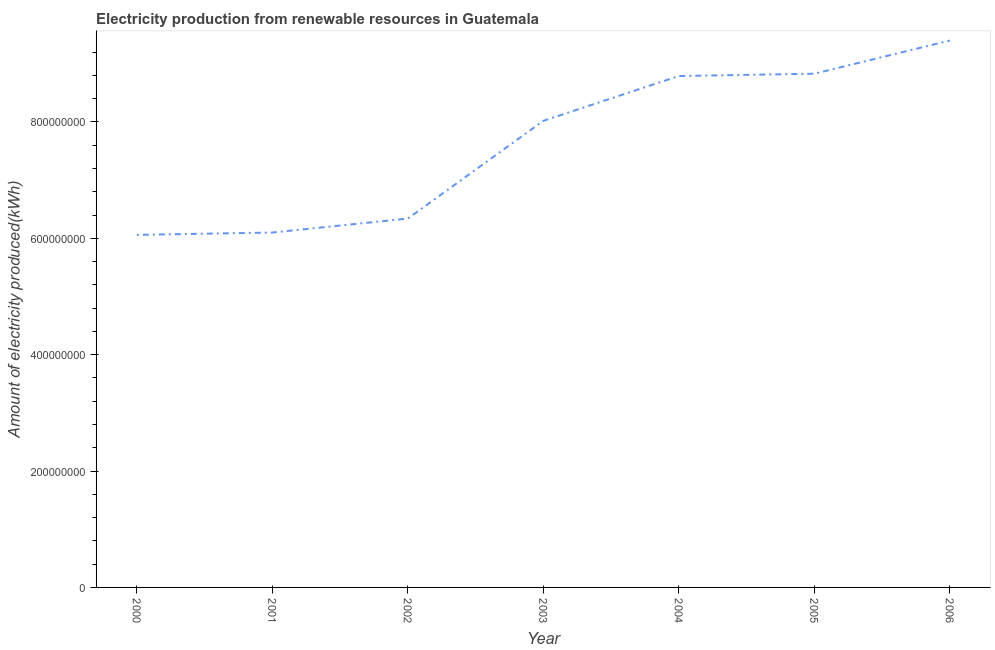What is the amount of electricity produced in 2001?
Your answer should be compact. 6.10e+08. Across all years, what is the maximum amount of electricity produced?
Make the answer very short. 9.40e+08. Across all years, what is the minimum amount of electricity produced?
Your answer should be very brief. 6.06e+08. In which year was the amount of electricity produced maximum?
Keep it short and to the point. 2006. In which year was the amount of electricity produced minimum?
Offer a very short reply. 2000. What is the sum of the amount of electricity produced?
Make the answer very short. 5.35e+09. What is the difference between the amount of electricity produced in 2001 and 2002?
Make the answer very short. -2.40e+07. What is the average amount of electricity produced per year?
Ensure brevity in your answer.  7.65e+08. What is the median amount of electricity produced?
Your answer should be compact. 8.02e+08. What is the ratio of the amount of electricity produced in 2001 to that in 2004?
Make the answer very short. 0.69. Is the amount of electricity produced in 2001 less than that in 2005?
Keep it short and to the point. Yes. What is the difference between the highest and the second highest amount of electricity produced?
Keep it short and to the point. 5.70e+07. Is the sum of the amount of electricity produced in 2001 and 2003 greater than the maximum amount of electricity produced across all years?
Provide a short and direct response. Yes. What is the difference between the highest and the lowest amount of electricity produced?
Ensure brevity in your answer.  3.34e+08. In how many years, is the amount of electricity produced greater than the average amount of electricity produced taken over all years?
Provide a short and direct response. 4. What is the difference between two consecutive major ticks on the Y-axis?
Keep it short and to the point. 2.00e+08. Does the graph contain any zero values?
Your answer should be compact. No. What is the title of the graph?
Your answer should be very brief. Electricity production from renewable resources in Guatemala. What is the label or title of the Y-axis?
Ensure brevity in your answer.  Amount of electricity produced(kWh). What is the Amount of electricity produced(kWh) in 2000?
Make the answer very short. 6.06e+08. What is the Amount of electricity produced(kWh) of 2001?
Your answer should be very brief. 6.10e+08. What is the Amount of electricity produced(kWh) in 2002?
Keep it short and to the point. 6.34e+08. What is the Amount of electricity produced(kWh) in 2003?
Keep it short and to the point. 8.02e+08. What is the Amount of electricity produced(kWh) of 2004?
Your response must be concise. 8.79e+08. What is the Amount of electricity produced(kWh) of 2005?
Offer a very short reply. 8.83e+08. What is the Amount of electricity produced(kWh) in 2006?
Your answer should be very brief. 9.40e+08. What is the difference between the Amount of electricity produced(kWh) in 2000 and 2001?
Ensure brevity in your answer.  -4.00e+06. What is the difference between the Amount of electricity produced(kWh) in 2000 and 2002?
Keep it short and to the point. -2.80e+07. What is the difference between the Amount of electricity produced(kWh) in 2000 and 2003?
Your answer should be compact. -1.96e+08. What is the difference between the Amount of electricity produced(kWh) in 2000 and 2004?
Keep it short and to the point. -2.73e+08. What is the difference between the Amount of electricity produced(kWh) in 2000 and 2005?
Make the answer very short. -2.77e+08. What is the difference between the Amount of electricity produced(kWh) in 2000 and 2006?
Your answer should be compact. -3.34e+08. What is the difference between the Amount of electricity produced(kWh) in 2001 and 2002?
Ensure brevity in your answer.  -2.40e+07. What is the difference between the Amount of electricity produced(kWh) in 2001 and 2003?
Your response must be concise. -1.92e+08. What is the difference between the Amount of electricity produced(kWh) in 2001 and 2004?
Ensure brevity in your answer.  -2.69e+08. What is the difference between the Amount of electricity produced(kWh) in 2001 and 2005?
Offer a very short reply. -2.73e+08. What is the difference between the Amount of electricity produced(kWh) in 2001 and 2006?
Offer a terse response. -3.30e+08. What is the difference between the Amount of electricity produced(kWh) in 2002 and 2003?
Your answer should be compact. -1.68e+08. What is the difference between the Amount of electricity produced(kWh) in 2002 and 2004?
Make the answer very short. -2.45e+08. What is the difference between the Amount of electricity produced(kWh) in 2002 and 2005?
Offer a very short reply. -2.49e+08. What is the difference between the Amount of electricity produced(kWh) in 2002 and 2006?
Your answer should be very brief. -3.06e+08. What is the difference between the Amount of electricity produced(kWh) in 2003 and 2004?
Your response must be concise. -7.70e+07. What is the difference between the Amount of electricity produced(kWh) in 2003 and 2005?
Ensure brevity in your answer.  -8.10e+07. What is the difference between the Amount of electricity produced(kWh) in 2003 and 2006?
Ensure brevity in your answer.  -1.38e+08. What is the difference between the Amount of electricity produced(kWh) in 2004 and 2005?
Your answer should be very brief. -4.00e+06. What is the difference between the Amount of electricity produced(kWh) in 2004 and 2006?
Your response must be concise. -6.10e+07. What is the difference between the Amount of electricity produced(kWh) in 2005 and 2006?
Provide a short and direct response. -5.70e+07. What is the ratio of the Amount of electricity produced(kWh) in 2000 to that in 2001?
Ensure brevity in your answer.  0.99. What is the ratio of the Amount of electricity produced(kWh) in 2000 to that in 2002?
Your response must be concise. 0.96. What is the ratio of the Amount of electricity produced(kWh) in 2000 to that in 2003?
Offer a terse response. 0.76. What is the ratio of the Amount of electricity produced(kWh) in 2000 to that in 2004?
Provide a succinct answer. 0.69. What is the ratio of the Amount of electricity produced(kWh) in 2000 to that in 2005?
Offer a very short reply. 0.69. What is the ratio of the Amount of electricity produced(kWh) in 2000 to that in 2006?
Your response must be concise. 0.65. What is the ratio of the Amount of electricity produced(kWh) in 2001 to that in 2003?
Your answer should be compact. 0.76. What is the ratio of the Amount of electricity produced(kWh) in 2001 to that in 2004?
Your response must be concise. 0.69. What is the ratio of the Amount of electricity produced(kWh) in 2001 to that in 2005?
Ensure brevity in your answer.  0.69. What is the ratio of the Amount of electricity produced(kWh) in 2001 to that in 2006?
Provide a succinct answer. 0.65. What is the ratio of the Amount of electricity produced(kWh) in 2002 to that in 2003?
Provide a succinct answer. 0.79. What is the ratio of the Amount of electricity produced(kWh) in 2002 to that in 2004?
Offer a very short reply. 0.72. What is the ratio of the Amount of electricity produced(kWh) in 2002 to that in 2005?
Offer a terse response. 0.72. What is the ratio of the Amount of electricity produced(kWh) in 2002 to that in 2006?
Your response must be concise. 0.67. What is the ratio of the Amount of electricity produced(kWh) in 2003 to that in 2004?
Make the answer very short. 0.91. What is the ratio of the Amount of electricity produced(kWh) in 2003 to that in 2005?
Your response must be concise. 0.91. What is the ratio of the Amount of electricity produced(kWh) in 2003 to that in 2006?
Provide a succinct answer. 0.85. What is the ratio of the Amount of electricity produced(kWh) in 2004 to that in 2005?
Give a very brief answer. 0.99. What is the ratio of the Amount of electricity produced(kWh) in 2004 to that in 2006?
Offer a very short reply. 0.94. What is the ratio of the Amount of electricity produced(kWh) in 2005 to that in 2006?
Your response must be concise. 0.94. 